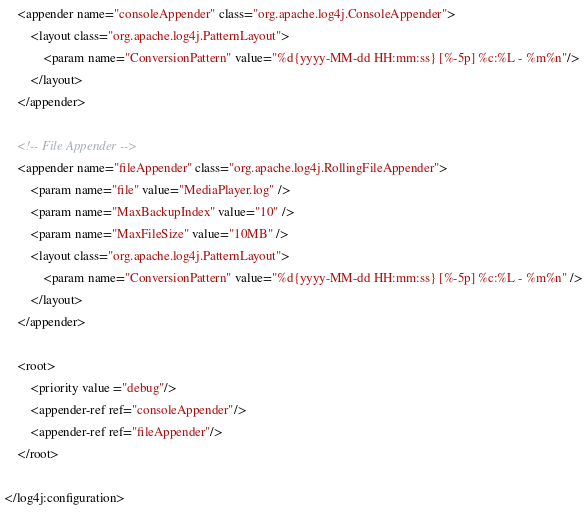<code> <loc_0><loc_0><loc_500><loc_500><_XML_>    <appender name="consoleAppender" class="org.apache.log4j.ConsoleAppender">
        <layout class="org.apache.log4j.PatternLayout">
            <param name="ConversionPattern" value="%d{yyyy-MM-dd HH:mm:ss} [%-5p] %c:%L - %m%n"/>
        </layout>
    </appender>

    <!-- File Appender -->
    <appender name="fileAppender" class="org.apache.log4j.RollingFileAppender">
        <param name="file" value="MediaPlayer.log" />
        <param name="MaxBackupIndex" value="10" />
        <param name="MaxFileSize" value="10MB" />
        <layout class="org.apache.log4j.PatternLayout">
            <param name="ConversionPattern" value="%d{yyyy-MM-dd HH:mm:ss} [%-5p] %c:%L - %m%n" />
        </layout>
    </appender>

    <root>
        <priority value ="debug"/>
        <appender-ref ref="consoleAppender"/>
        <appender-ref ref="fileAppender"/>
    </root>

</log4j:configuration>
</code> 